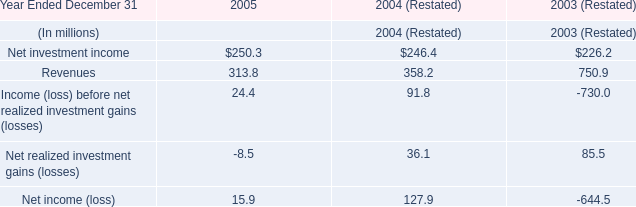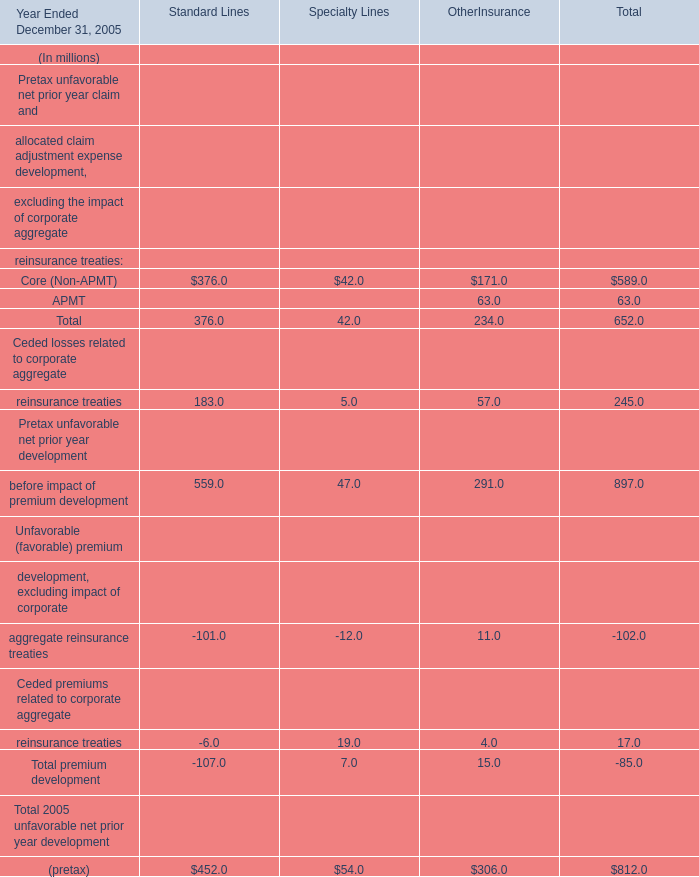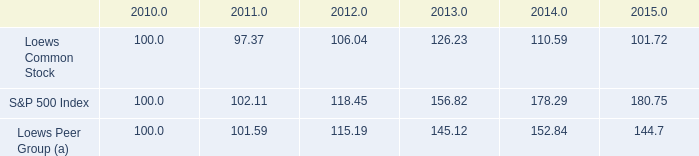What's the sum of all Specialty Lines that are greater than 45 in 2005? (in million) 
Computations: (47 + 54)
Answer: 101.0. 